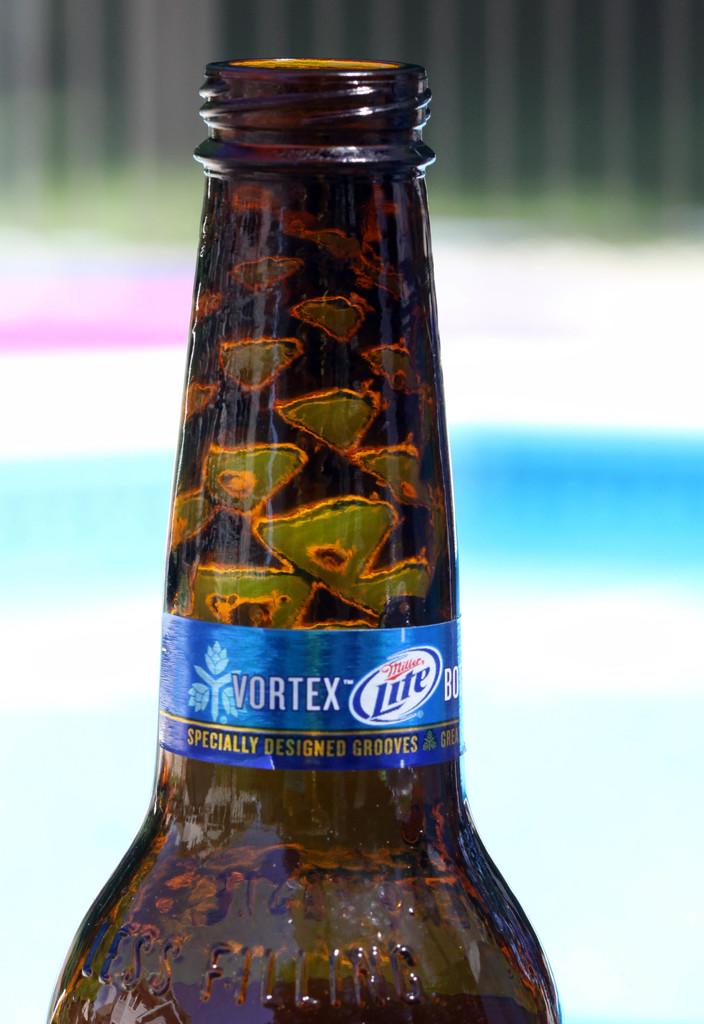What is specially designed?
Ensure brevity in your answer.  Grooves. 